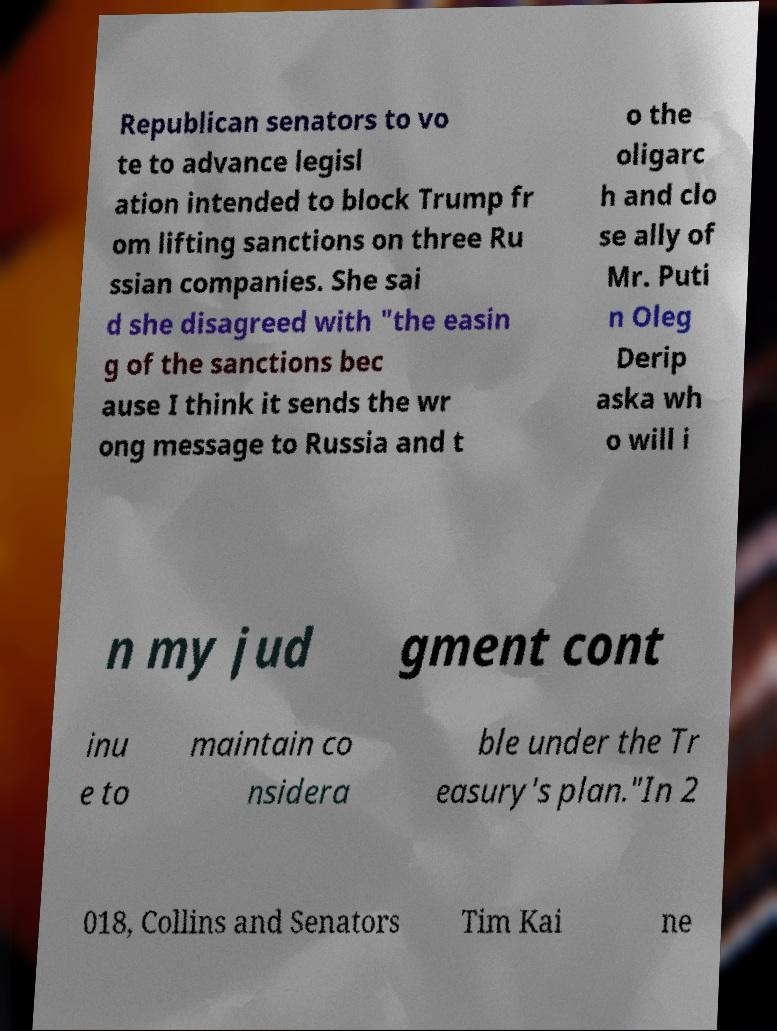I need the written content from this picture converted into text. Can you do that? Republican senators to vo te to advance legisl ation intended to block Trump fr om lifting sanctions on three Ru ssian companies. She sai d she disagreed with "the easin g of the sanctions bec ause I think it sends the wr ong message to Russia and t o the oligarc h and clo se ally of Mr. Puti n Oleg Derip aska wh o will i n my jud gment cont inu e to maintain co nsidera ble under the Tr easury's plan."In 2 018, Collins and Senators Tim Kai ne 